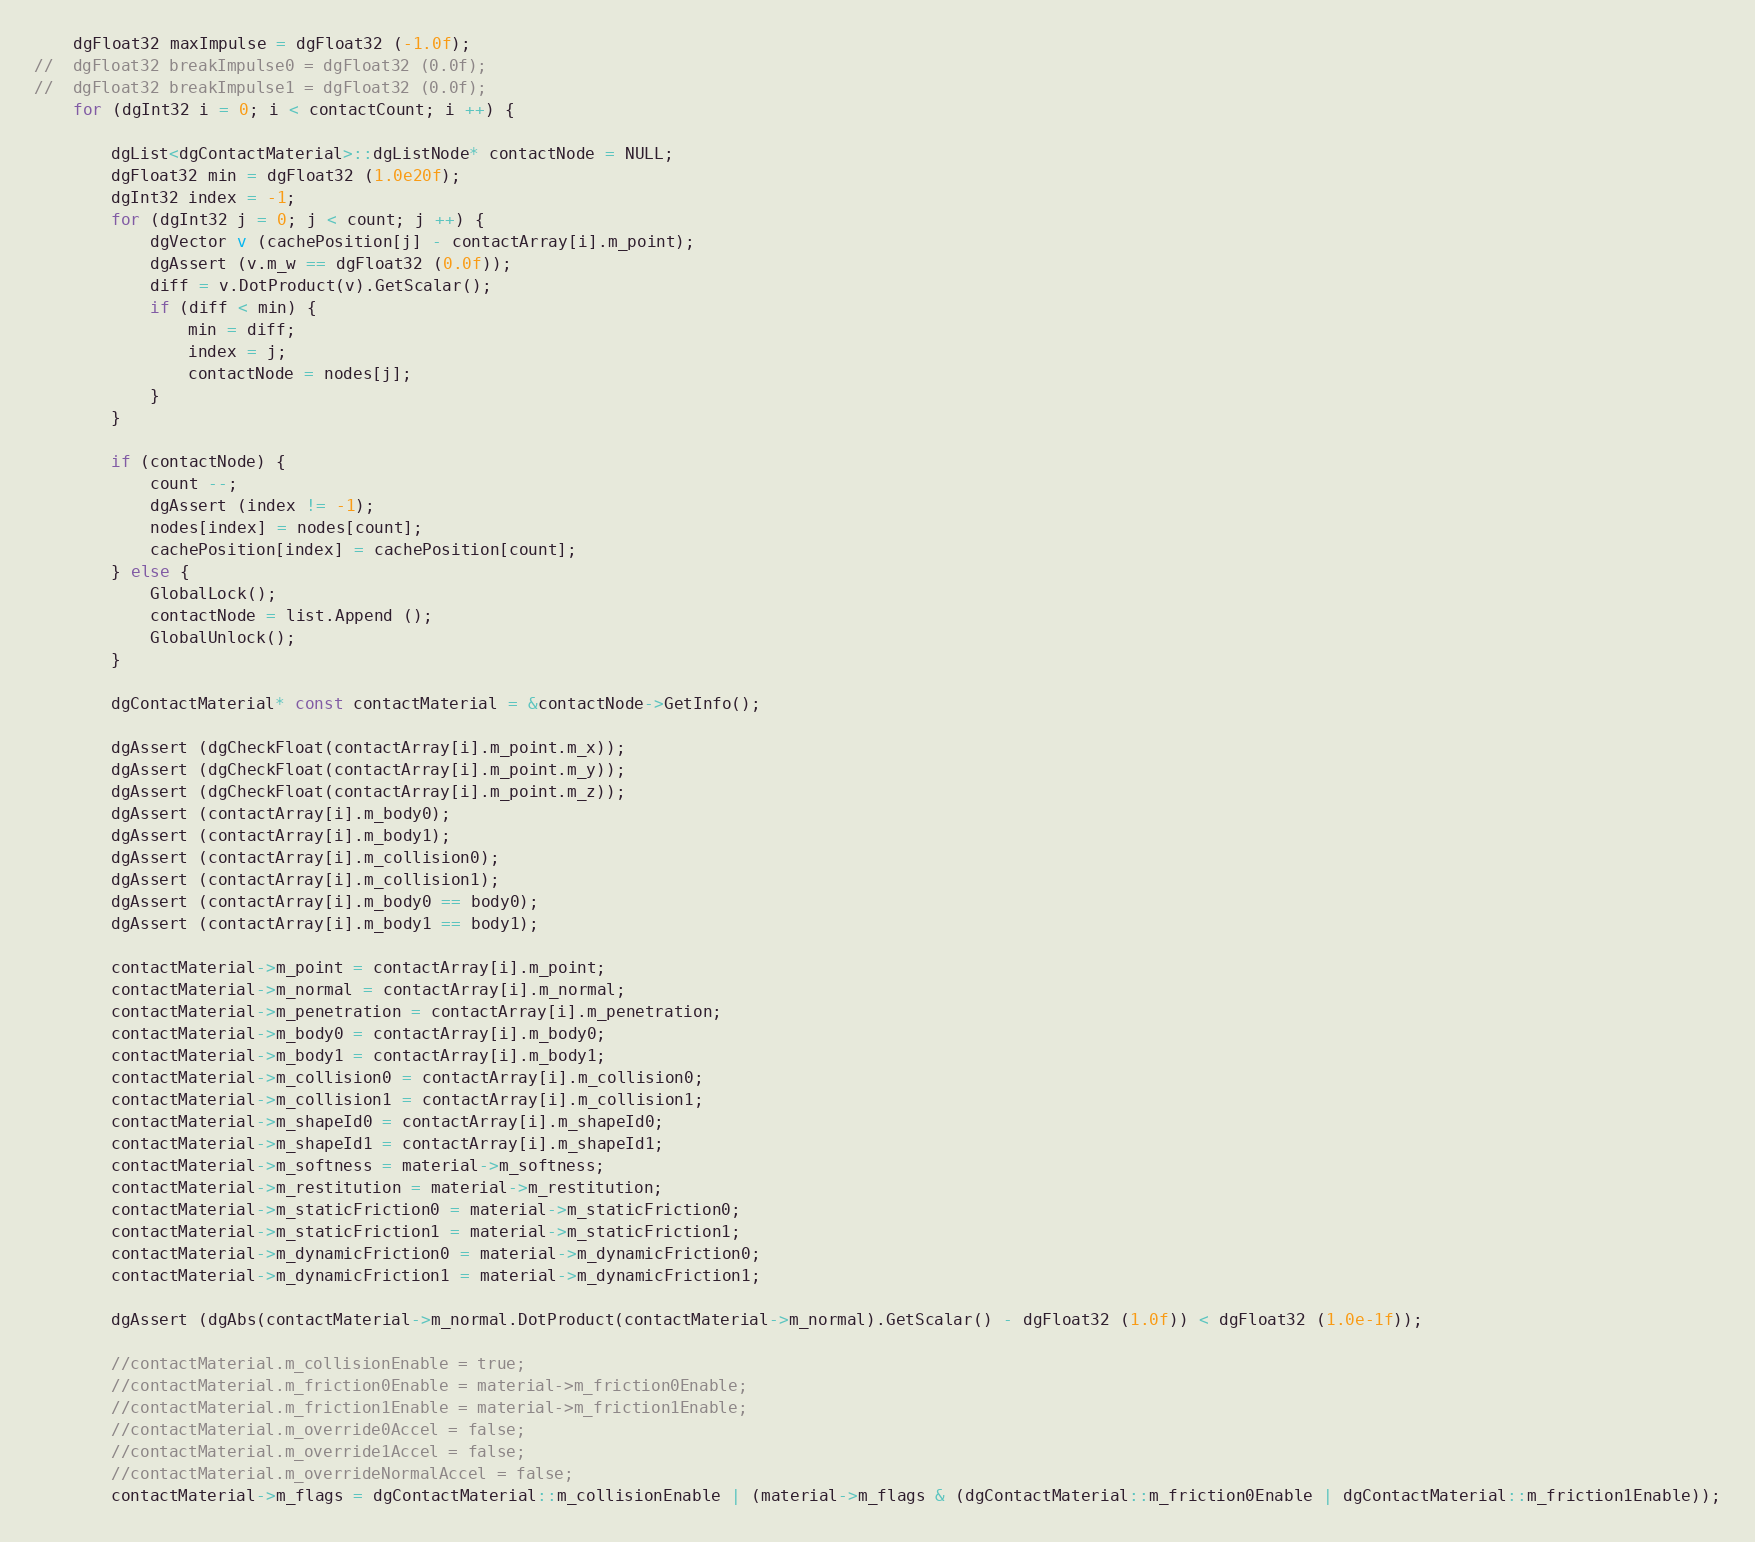Convert code to text. <code><loc_0><loc_0><loc_500><loc_500><_C++_>	dgFloat32 maxImpulse = dgFloat32 (-1.0f);
//	dgFloat32 breakImpulse0 = dgFloat32 (0.0f);
//	dgFloat32 breakImpulse1 = dgFloat32 (0.0f);
	for (dgInt32 i = 0; i < contactCount; i ++) {

		dgList<dgContactMaterial>::dgListNode* contactNode = NULL;
		dgFloat32 min = dgFloat32 (1.0e20f);
		dgInt32 index = -1;
		for (dgInt32 j = 0; j < count; j ++) {
			dgVector v (cachePosition[j] - contactArray[i].m_point);
			dgAssert (v.m_w == dgFloat32 (0.0f));
			diff = v.DotProduct(v).GetScalar();
			if (diff < min) {
				min = diff;
				index = j;
				contactNode = nodes[j];
			}
		}

		if (contactNode) {
			count --;
			dgAssert (index != -1);
			nodes[index] = nodes[count];
			cachePosition[index] = cachePosition[count];
		} else {
			GlobalLock();
			contactNode = list.Append ();
			GlobalUnlock();
		}

		dgContactMaterial* const contactMaterial = &contactNode->GetInfo();

		dgAssert (dgCheckFloat(contactArray[i].m_point.m_x));
		dgAssert (dgCheckFloat(contactArray[i].m_point.m_y));
		dgAssert (dgCheckFloat(contactArray[i].m_point.m_z));
		dgAssert (contactArray[i].m_body0);
		dgAssert (contactArray[i].m_body1);
		dgAssert (contactArray[i].m_collision0);
		dgAssert (contactArray[i].m_collision1);
		dgAssert (contactArray[i].m_body0 == body0);
		dgAssert (contactArray[i].m_body1 == body1);

		contactMaterial->m_point = contactArray[i].m_point;
		contactMaterial->m_normal = contactArray[i].m_normal;
		contactMaterial->m_penetration = contactArray[i].m_penetration;
		contactMaterial->m_body0 = contactArray[i].m_body0;
		contactMaterial->m_body1 = contactArray[i].m_body1;
		contactMaterial->m_collision0 = contactArray[i].m_collision0;
		contactMaterial->m_collision1 = contactArray[i].m_collision1;
		contactMaterial->m_shapeId0 = contactArray[i].m_shapeId0;
		contactMaterial->m_shapeId1 = contactArray[i].m_shapeId1;
		contactMaterial->m_softness = material->m_softness;
		contactMaterial->m_restitution = material->m_restitution;
		contactMaterial->m_staticFriction0 = material->m_staticFriction0;
		contactMaterial->m_staticFriction1 = material->m_staticFriction1;
		contactMaterial->m_dynamicFriction0 = material->m_dynamicFriction0;
		contactMaterial->m_dynamicFriction1 = material->m_dynamicFriction1;

		dgAssert (dgAbs(contactMaterial->m_normal.DotProduct(contactMaterial->m_normal).GetScalar() - dgFloat32 (1.0f)) < dgFloat32 (1.0e-1f));

		//contactMaterial.m_collisionEnable = true;
		//contactMaterial.m_friction0Enable = material->m_friction0Enable;
		//contactMaterial.m_friction1Enable = material->m_friction1Enable;
		//contactMaterial.m_override0Accel = false;
		//contactMaterial.m_override1Accel = false;
		//contactMaterial.m_overrideNormalAccel = false;
		contactMaterial->m_flags = dgContactMaterial::m_collisionEnable | (material->m_flags & (dgContactMaterial::m_friction0Enable | dgContactMaterial::m_friction1Enable));</code> 